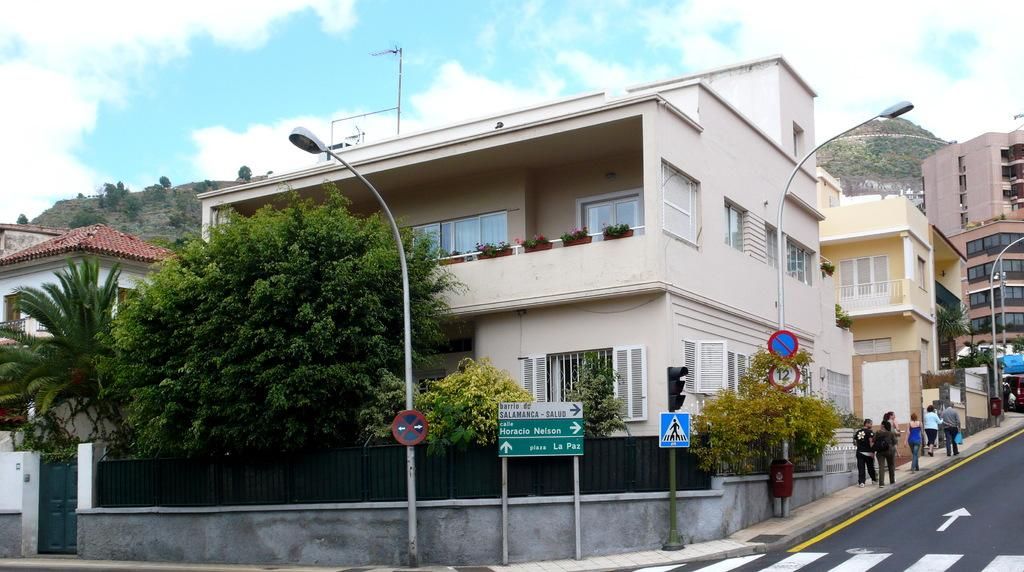What type of structures can be seen in the image? There are buildings in the image. What type of lighting is present in the image? There are street lamps in the image. What type of poles are visible in the image? There are sign poles in the image. What type of vegetation is present in the image? There are trees and plants in the image. What type of natural feature is present in the image? There are hills in the image. What is visible at the top of the image? The sky is visible at the top of the image. What can be seen in the sky? Clouds are present in the sky. What color are the jeans worn by the trees in the image? There are no jeans present in the image, as trees do not wear clothing. How many colors are present in the image? The provided facts do not specify the number of colors present in the image, so it cannot be definitively answered. 